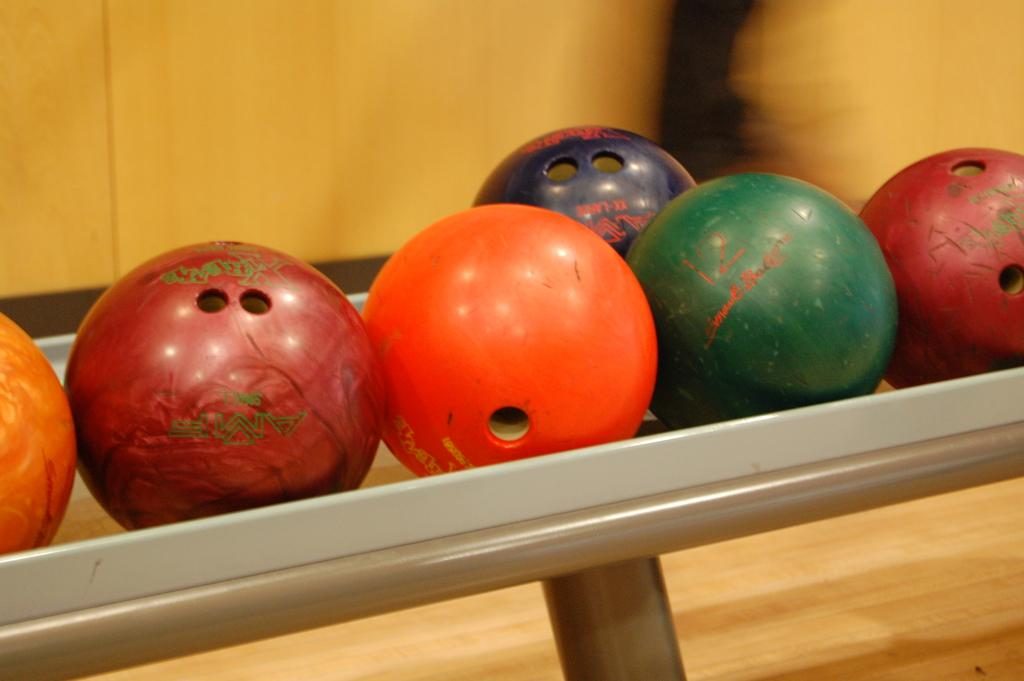What objects are in the center of the image? There are balls in the center of the image. What type of material can be seen in the background of the image? There is a wooden wall in the background of the image. What is the surface at the bottom of the image made of? There is a wooden surface at the bottom of the image. What type of glove is being used to handle the balls in the image? There is no glove present in the image, and the balls are not being handled by anyone. 